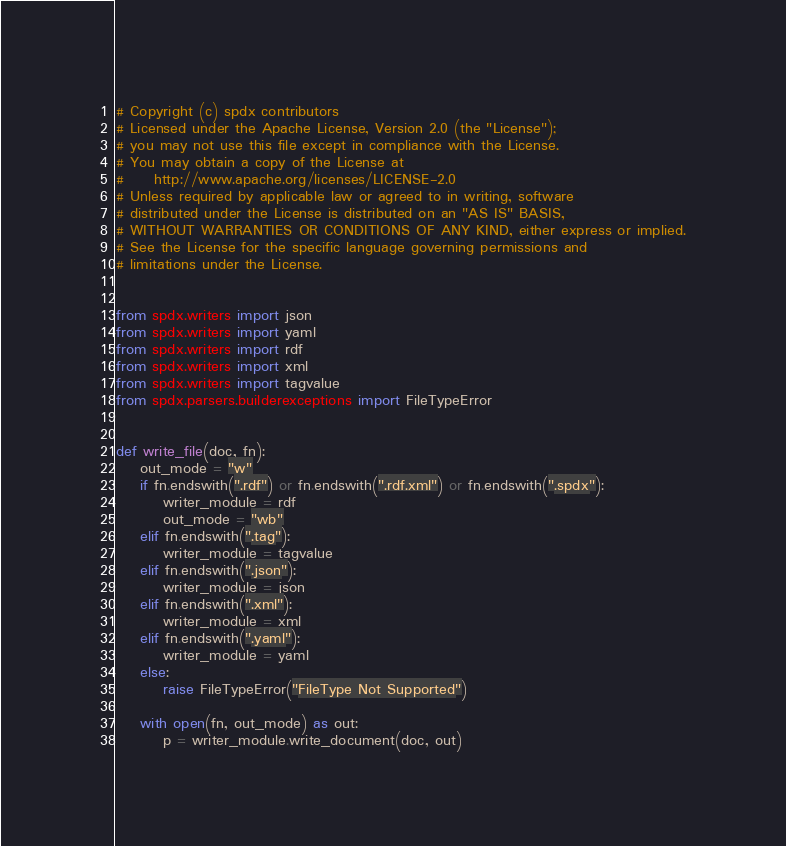Convert code to text. <code><loc_0><loc_0><loc_500><loc_500><_Python_># Copyright (c) spdx contributors
# Licensed under the Apache License, Version 2.0 (the "License");
# you may not use this file except in compliance with the License.
# You may obtain a copy of the License at
#     http://www.apache.org/licenses/LICENSE-2.0
# Unless required by applicable law or agreed to in writing, software
# distributed under the License is distributed on an "AS IS" BASIS,
# WITHOUT WARRANTIES OR CONDITIONS OF ANY KIND, either express or implied.
# See the License for the specific language governing permissions and
# limitations under the License.


from spdx.writers import json
from spdx.writers import yaml
from spdx.writers import rdf
from spdx.writers import xml
from spdx.writers import tagvalue
from spdx.parsers.builderexceptions import FileTypeError


def write_file(doc, fn):
    out_mode = "w"
    if fn.endswith(".rdf") or fn.endswith(".rdf.xml") or fn.endswith(".spdx"):
        writer_module = rdf
        out_mode = "wb"
    elif fn.endswith(".tag"):
        writer_module = tagvalue
    elif fn.endswith(".json"):
        writer_module = json
    elif fn.endswith(".xml"):
        writer_module = xml
    elif fn.endswith(".yaml"):
        writer_module = yaml
    else:
        raise FileTypeError("FileType Not Supported")

    with open(fn, out_mode) as out:
        p = writer_module.write_document(doc, out)
</code> 